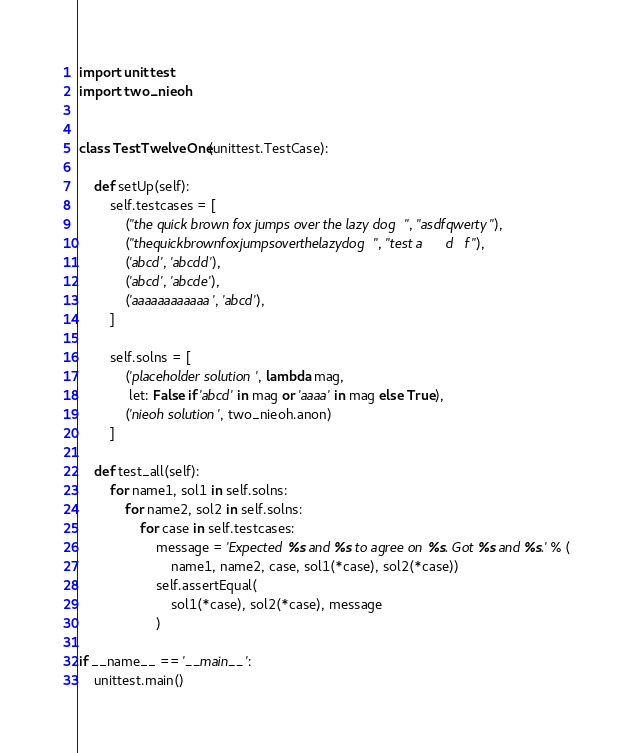<code> <loc_0><loc_0><loc_500><loc_500><_Python_>import unittest
import two_nieoh


class TestTwelveOne(unittest.TestCase):

    def setUp(self):
        self.testcases = [
            ("the quick brown fox jumps over the lazy dog", "asdfqwerty"),
            ("thequickbrownfoxjumpsoverthelazydog", "test a      d   f"),
            ('abcd', 'abcdd'),
            ('abcd', 'abcde'),
            ('aaaaaaaaaaaa', 'abcd'),
        ]

        self.solns = [
            ('placeholder solution', lambda mag,
             let: False if 'abcd' in mag or 'aaaa' in mag else True),
            ('nieoh solution', two_nieoh.anon)
        ]

    def test_all(self):
        for name1, sol1 in self.solns:
            for name2, sol2 in self.solns:
                for case in self.testcases:
                    message = 'Expected %s and %s to agree on %s. Got %s and %s.' % (
                        name1, name2, case, sol1(*case), sol2(*case))
                    self.assertEqual(
                        sol1(*case), sol2(*case), message
                    )

if __name__ == '__main__':
    unittest.main()
</code> 